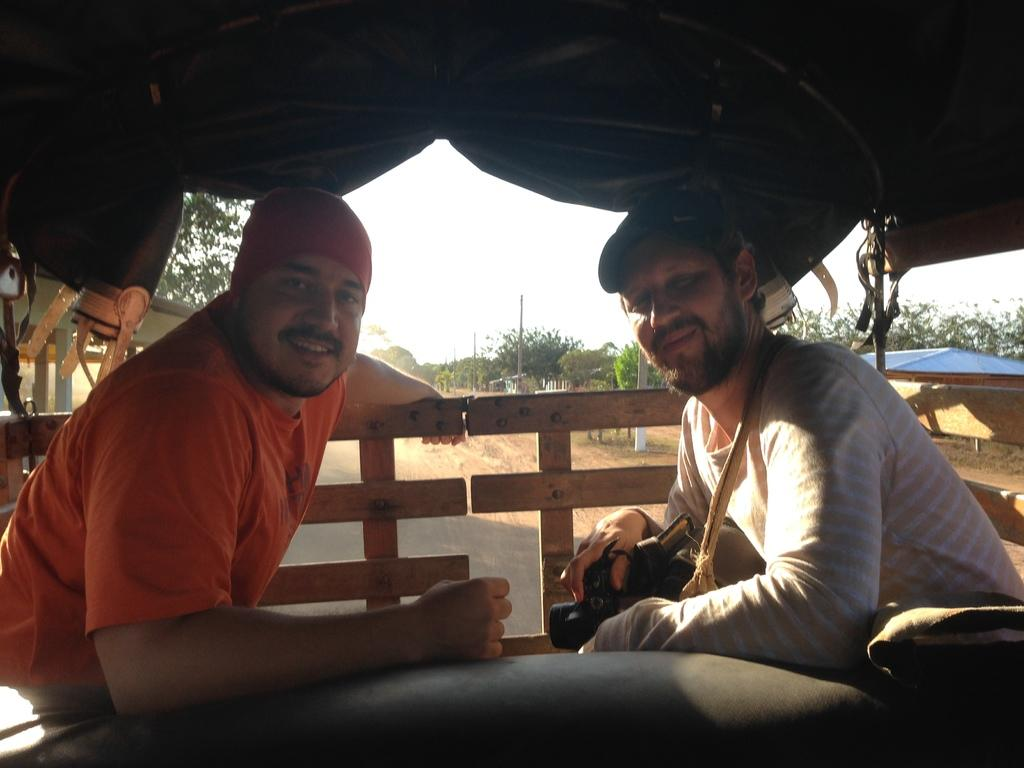How many people are in the image? There are two persons in the image. What is the facial expression of the persons in the image? The persons are smiling. What structures can be seen in the image? There is a fence, a tent, and sheds in the image. What type of pathway is present in the image? There is a road in the image. What type of vegetation is visible in the image? There are trees in the image. What other objects can be seen in the image? There are poles in the image. What is visible in the background of the image? The sky is visible in the background of the image. What type of yoke is being used by the persons in the image? There is no yoke present in the image. How do the persons pull the yoke in the image? There is no yoke or pulling action depicted in the image. 